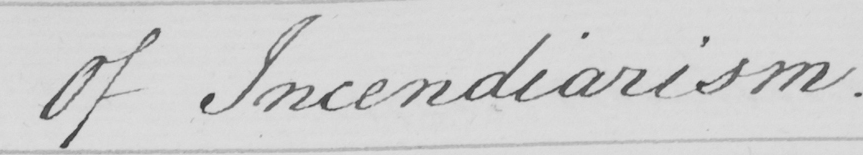Please provide the text content of this handwritten line. Of Incendiarism 